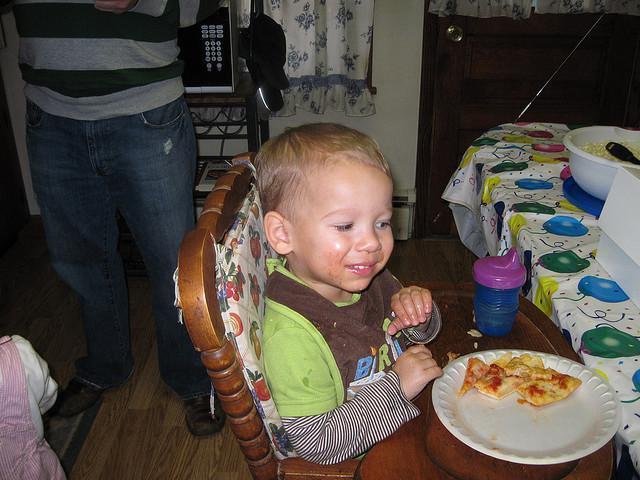How many people can be seen?
Give a very brief answer. 2. How many dining tables are visible?
Give a very brief answer. 2. How many bottles are there?
Give a very brief answer. 1. How many pizzas are in the picture?
Give a very brief answer. 1. 